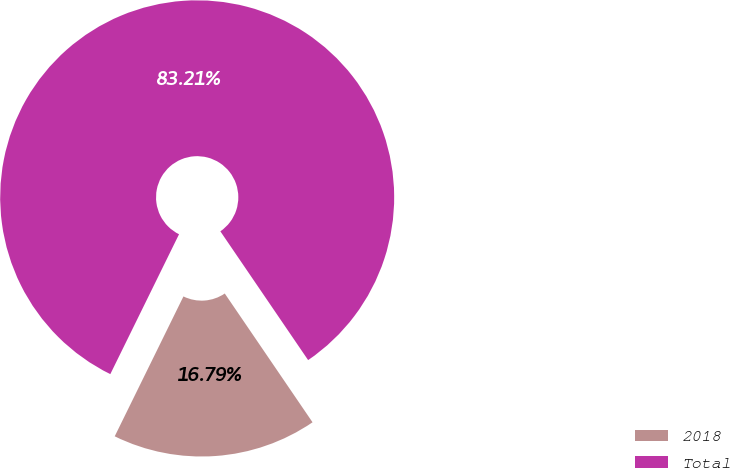<chart> <loc_0><loc_0><loc_500><loc_500><pie_chart><fcel>2018<fcel>Total<nl><fcel>16.79%<fcel>83.21%<nl></chart> 